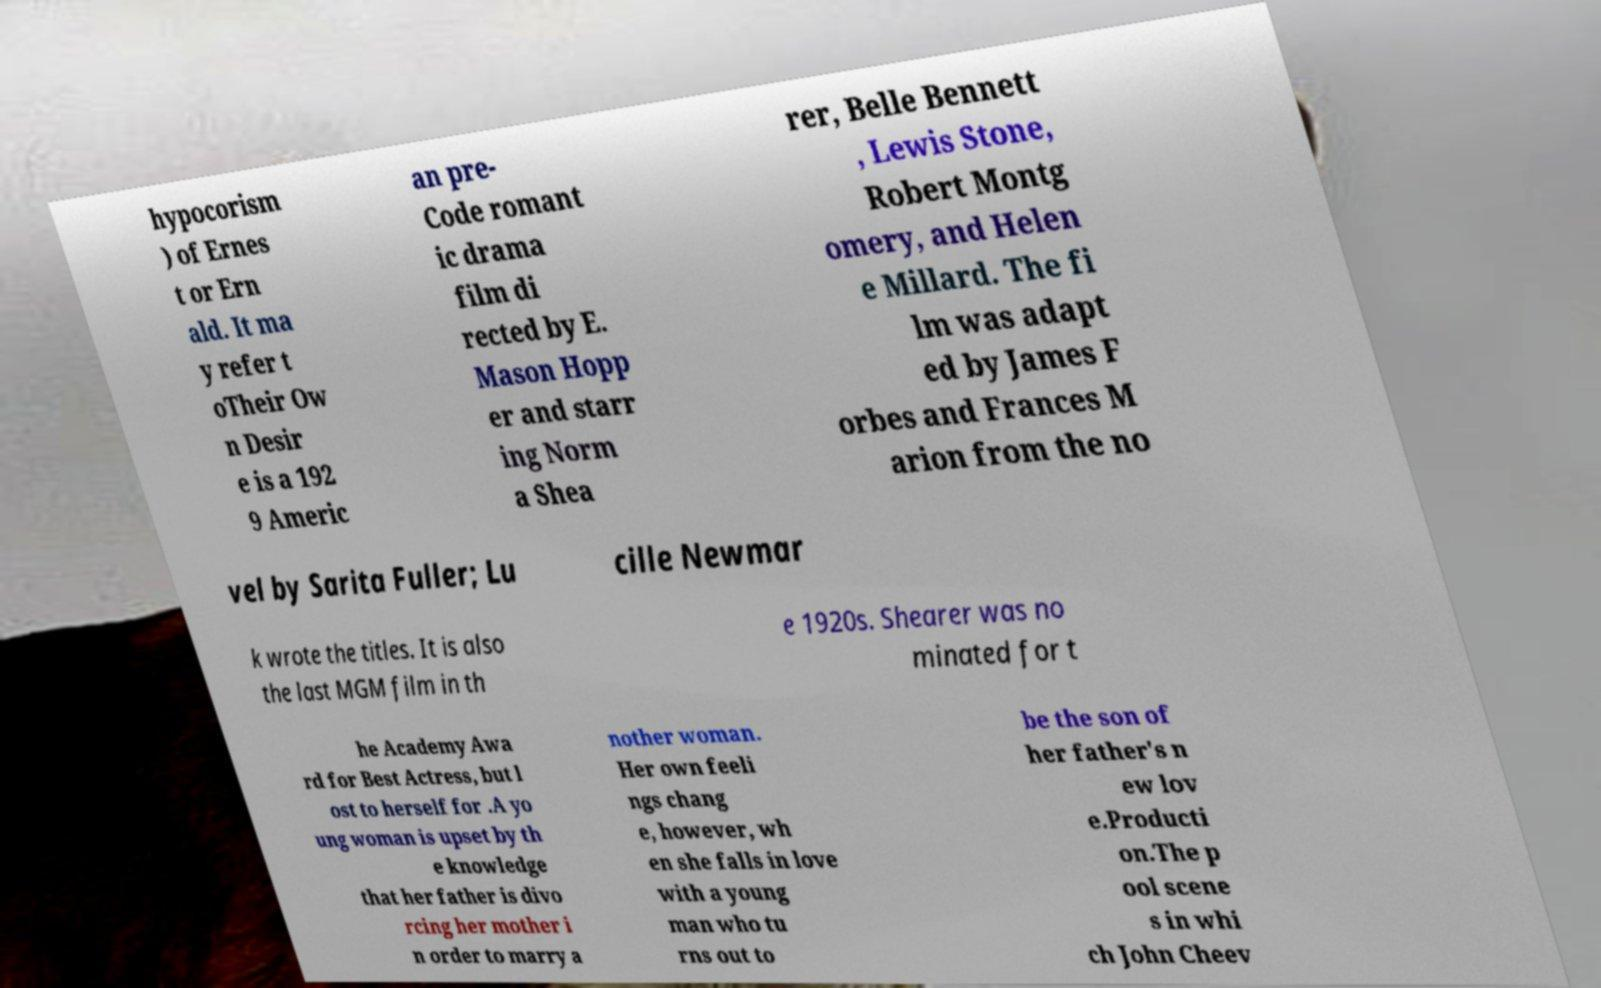What messages or text are displayed in this image? I need them in a readable, typed format. hypocorism ) of Ernes t or Ern ald. It ma y refer t oTheir Ow n Desir e is a 192 9 Americ an pre- Code romant ic drama film di rected by E. Mason Hopp er and starr ing Norm a Shea rer, Belle Bennett , Lewis Stone, Robert Montg omery, and Helen e Millard. The fi lm was adapt ed by James F orbes and Frances M arion from the no vel by Sarita Fuller; Lu cille Newmar k wrote the titles. It is also the last MGM film in th e 1920s. Shearer was no minated for t he Academy Awa rd for Best Actress, but l ost to herself for .A yo ung woman is upset by th e knowledge that her father is divo rcing her mother i n order to marry a nother woman. Her own feeli ngs chang e, however, wh en she falls in love with a young man who tu rns out to be the son of her father's n ew lov e.Producti on.The p ool scene s in whi ch John Cheev 